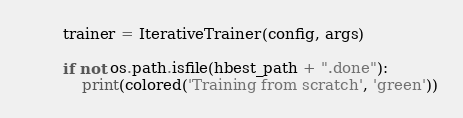Convert code to text. <code><loc_0><loc_0><loc_500><loc_500><_Python_>
        trainer = IterativeTrainer(config, args)

        if not os.path.isfile(hbest_path + ".done"):
            print(colored('Training from scratch', 'green'))</code> 